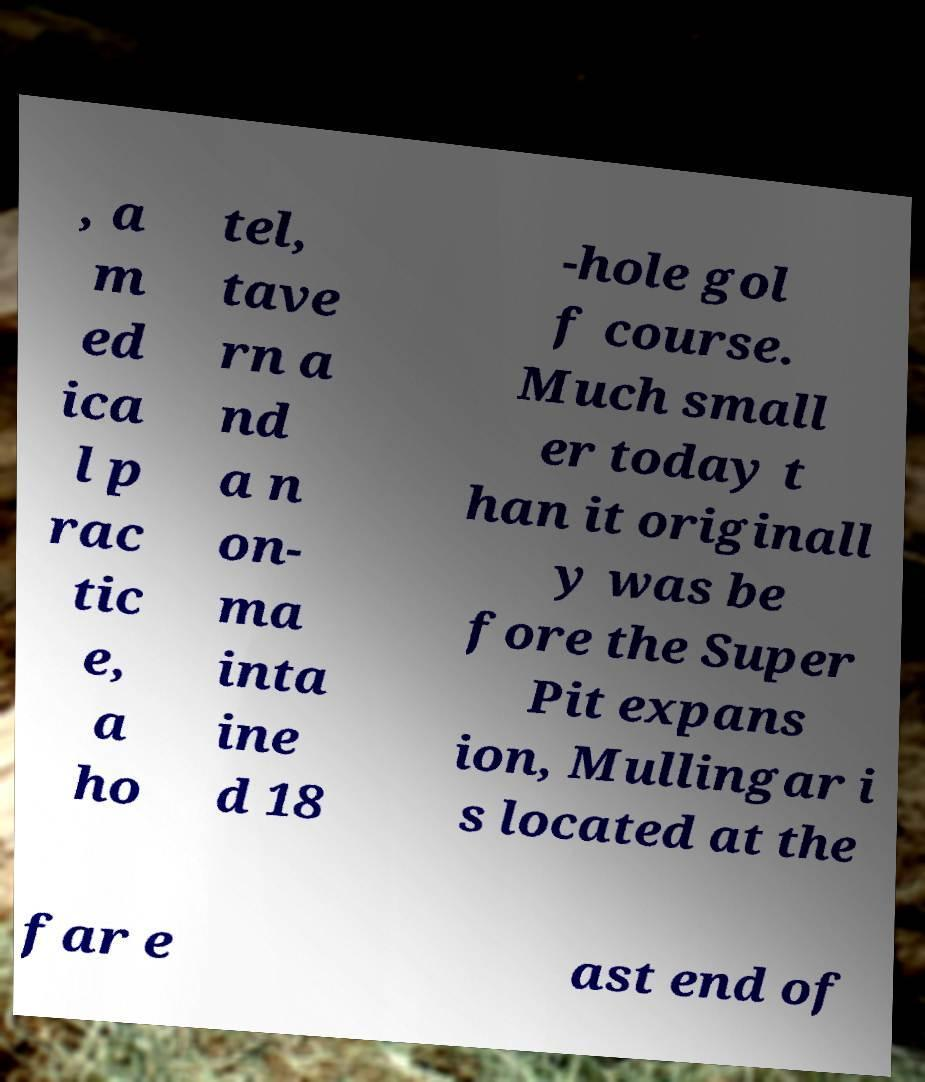Could you assist in decoding the text presented in this image and type it out clearly? , a m ed ica l p rac tic e, a ho tel, tave rn a nd a n on- ma inta ine d 18 -hole gol f course. Much small er today t han it originall y was be fore the Super Pit expans ion, Mullingar i s located at the far e ast end of 